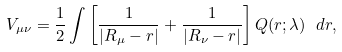<formula> <loc_0><loc_0><loc_500><loc_500>V _ { \mu \nu } = \frac { 1 } { 2 } \int \left [ \frac { 1 } { | { R } _ { \mu } - { r } | } + \frac { 1 } { | { R } _ { \nu } - { r } | } \right ] Q ( { r } ; \lambda ) \ d { r } ,</formula> 